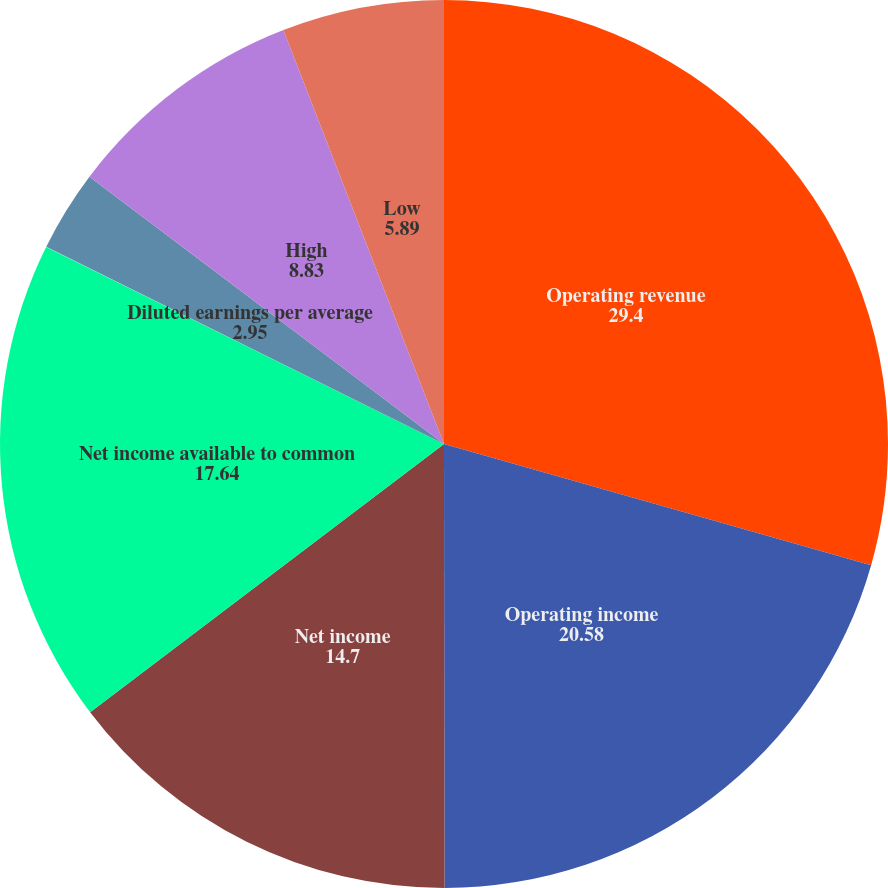Convert chart. <chart><loc_0><loc_0><loc_500><loc_500><pie_chart><fcel>Operating revenue<fcel>Operating income<fcel>Net income<fcel>Net income available to common<fcel>Basic earnings per average<fcel>Diluted earnings per average<fcel>High<fcel>Low<nl><fcel>29.4%<fcel>20.58%<fcel>14.7%<fcel>17.64%<fcel>0.01%<fcel>2.95%<fcel>8.83%<fcel>5.89%<nl></chart> 